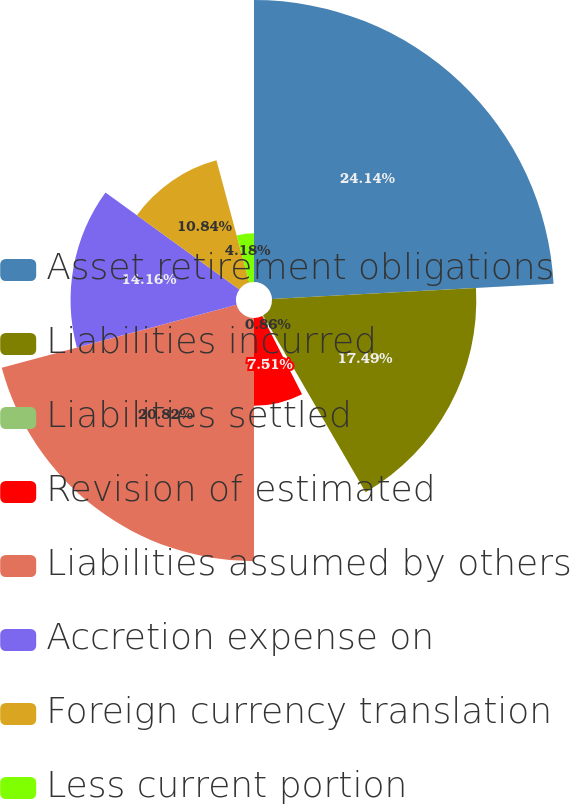Convert chart to OTSL. <chart><loc_0><loc_0><loc_500><loc_500><pie_chart><fcel>Asset retirement obligations<fcel>Liabilities incurred<fcel>Liabilities settled<fcel>Revision of estimated<fcel>Liabilities assumed by others<fcel>Accretion expense on<fcel>Foreign currency translation<fcel>Less current portion<nl><fcel>24.14%<fcel>17.49%<fcel>0.86%<fcel>7.51%<fcel>20.82%<fcel>14.16%<fcel>10.84%<fcel>4.18%<nl></chart> 